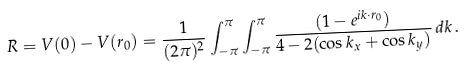Convert formula to latex. <formula><loc_0><loc_0><loc_500><loc_500>R = V ( 0 ) - V ( r _ { 0 } ) = \frac { 1 } { ( 2 \pi ) ^ { 2 } } \int _ { - \pi } ^ { \pi } \int _ { - \pi } ^ { \pi } \frac { ( 1 - e ^ { i k \cdot r _ { 0 } } ) } { 4 - 2 ( \cos k _ { x } + \cos k _ { y } ) } \, d k \, .</formula> 